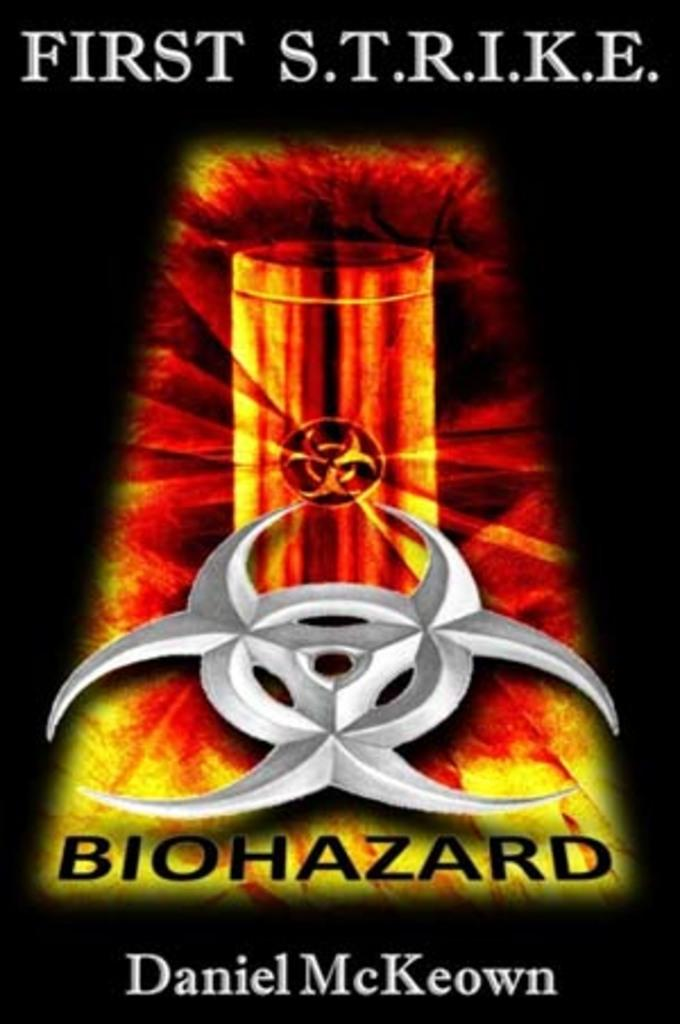Provide a one-sentence caption for the provided image. a book cover for First Strike biohazard by Daniel McKeown. 